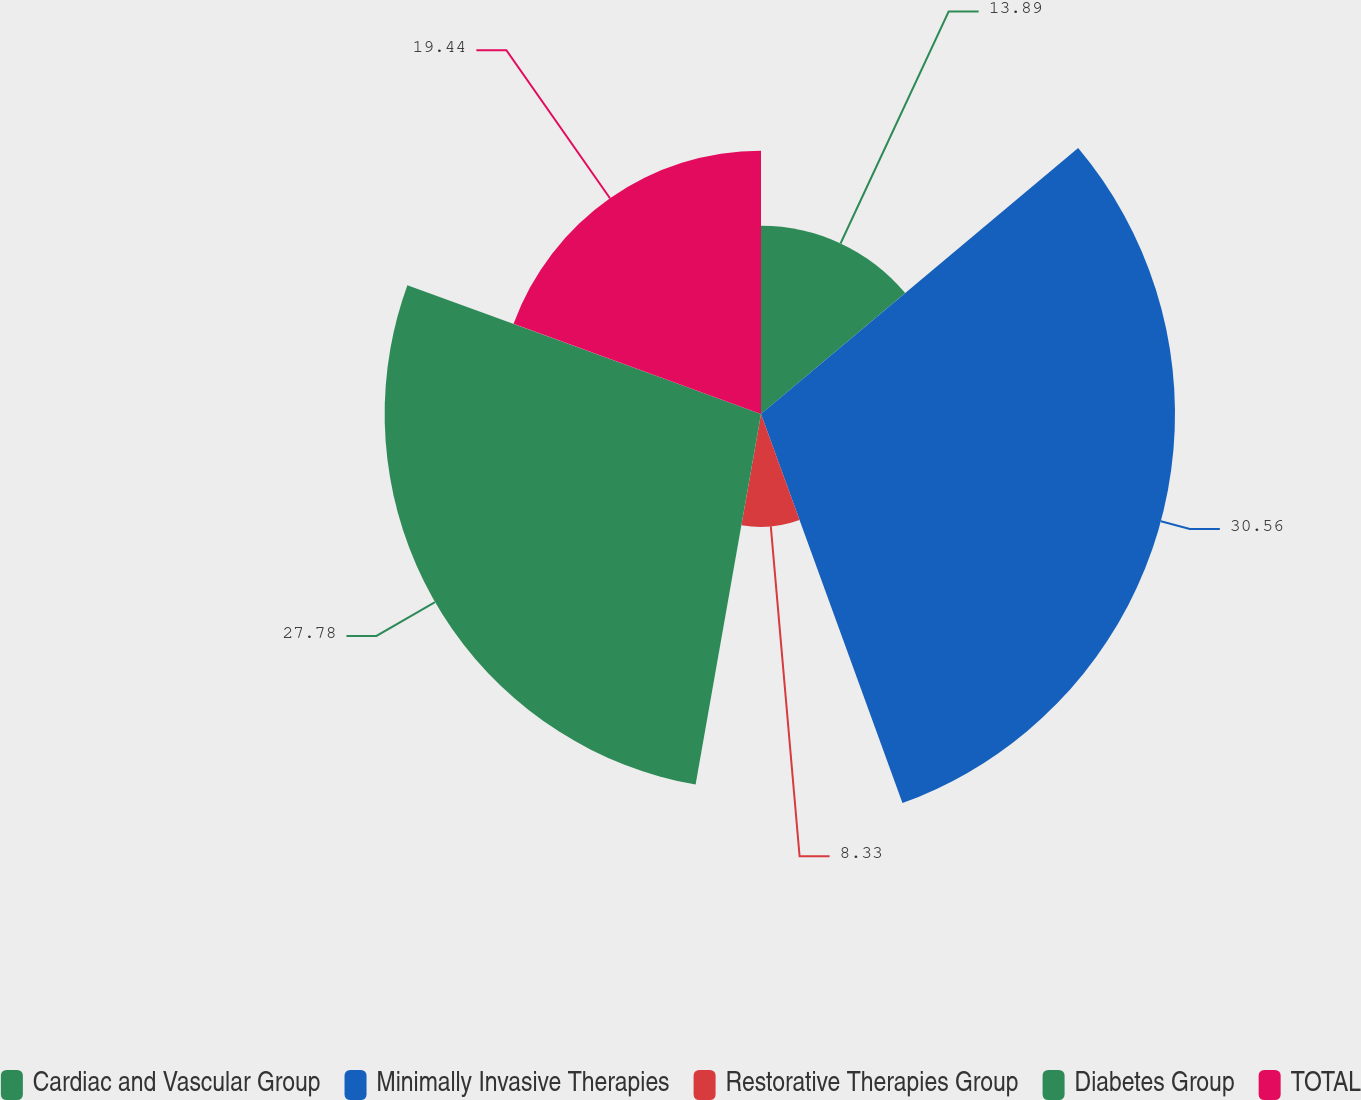Convert chart to OTSL. <chart><loc_0><loc_0><loc_500><loc_500><pie_chart><fcel>Cardiac and Vascular Group<fcel>Minimally Invasive Therapies<fcel>Restorative Therapies Group<fcel>Diabetes Group<fcel>TOTAL<nl><fcel>13.89%<fcel>30.56%<fcel>8.33%<fcel>27.78%<fcel>19.44%<nl></chart> 